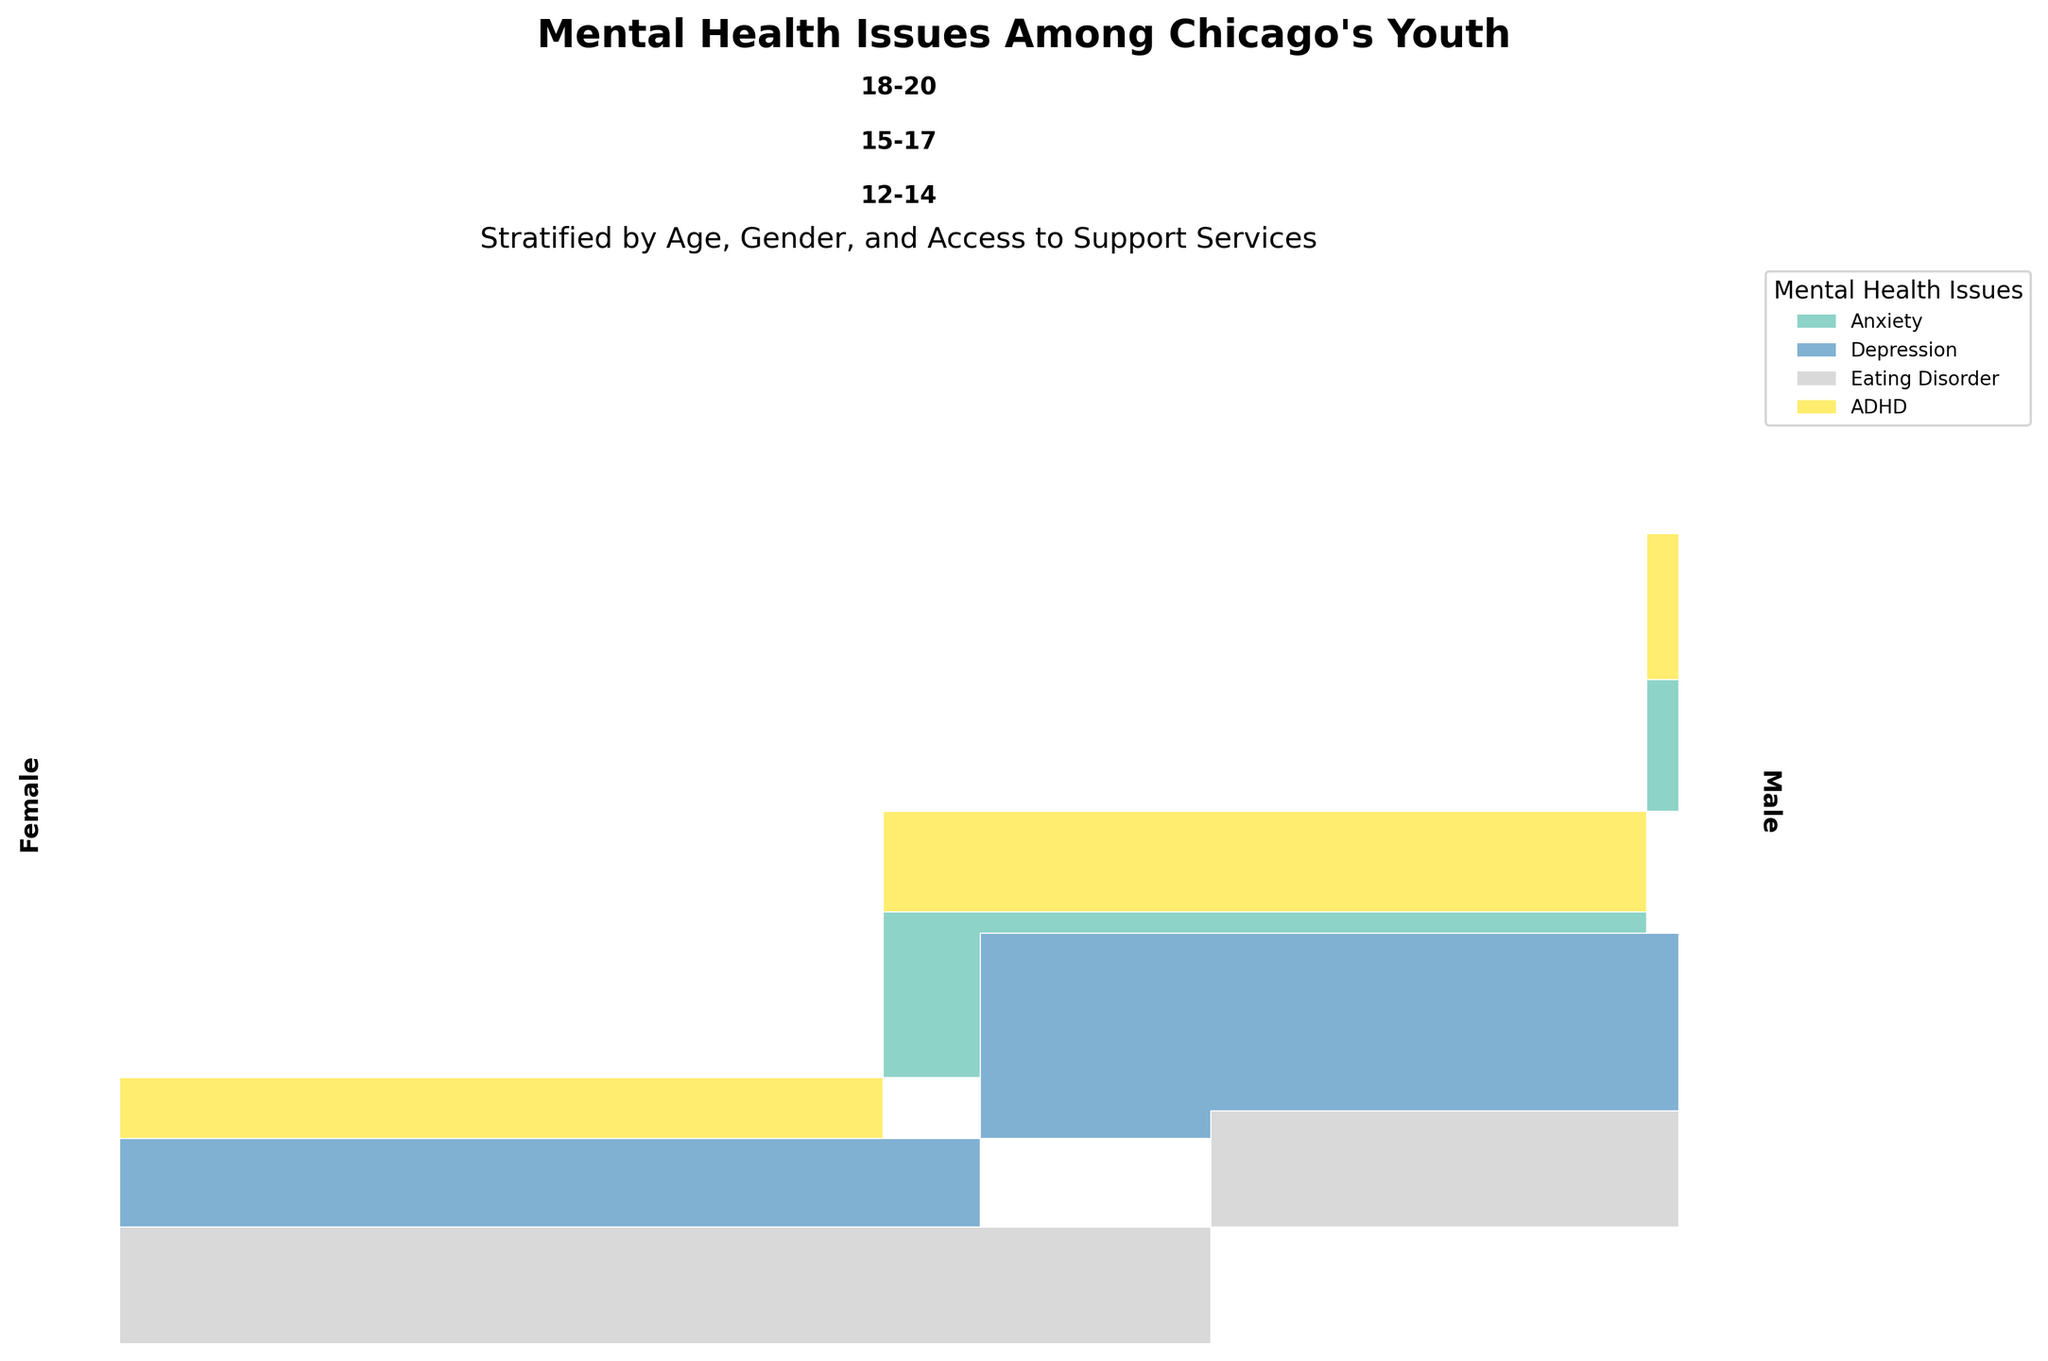What age group has the highest prevalence of anxiety? Look at the sections labeled "Anxiety" for each age group and compare their sizes. The largest section is "12-14"
Answer: 12-14 Which gender within the 15-17 age group has a higher prevalence of depression? Compare the rectangles for "Depression" for both "Male" and "Female" within the "15-17" age group. The female section is larger.
Answer: Female How does the access to support services affect the prevalence of eating disorders among males aged 18-20? Compare the rectangles for "Eating Disorder" under "High" and "Low" access to support services for "Males" aged "18-20." The count for "Low" is larger than "High."
Answer: Higher with low access What is the most common mental health issue among females aged 12-14 with low access to support? Identify the largest rectangle for "Females" aged "12-14" under "Low" access to support. The biggest is "Anxiety."
Answer: Anxiety Which mental health issue shows a more significant difference between high and low access to support services among males aged 12-14? Compare the size of rectangles under high and low access for "Anxiety" and "ADHD" among "Males" aged "12-14." Anxiety shows a larger difference.
Answer: Anxiety Which gender has more prevalent mental health issues in the "15-17" age group with low access to support? Compare the total size of rectangles for males and females under low access to support in the 15-17 age group. Females have larger sections.
Answer: Female What mental health issue has the highest prevalence among youth (any gender) aged 18-20 with high access to support services? Check the rectangles under high access for both genders in the 18-20 age group. The largest rectangle is "Eating Disorder" for females.
Answer: Eating Disorder How does the prevalence of ADHD compare between males and females aged 12-14? Compare the total sizes of the “ADHD” rectangles for males and females aged 12-14 under both high and low access. Males have larger sections overall.
Answer: Higher in males Is there a mental health issue where high access to support services leads to a higher prevalence? Look across all age groups and genders. Identify if there are any larger rectangles under high access compared to low access. The answer is "Eating Disorder" for females aged 18-20.
Answer: Eating Disorder for females (18-20) What is the least prevalent mental health issue among all age groups? Identify the smallest rectangles across all age groups and accesses. "Eating Disorder" for males appears to be overall smaller compared to others.
Answer: Eating Disorder for males 